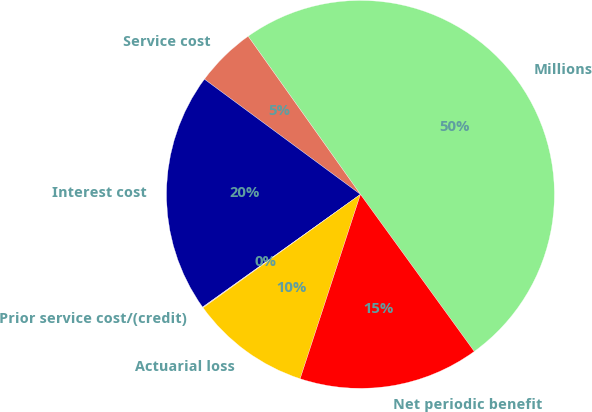Convert chart. <chart><loc_0><loc_0><loc_500><loc_500><pie_chart><fcel>Millions<fcel>Service cost<fcel>Interest cost<fcel>Prior service cost/(credit)<fcel>Actuarial loss<fcel>Net periodic benefit<nl><fcel>49.85%<fcel>5.05%<fcel>19.99%<fcel>0.07%<fcel>10.03%<fcel>15.01%<nl></chart> 